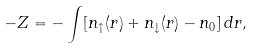Convert formula to latex. <formula><loc_0><loc_0><loc_500><loc_500>- Z = - \int [ n _ { \uparrow } ( r ) + n _ { \downarrow } ( r ) - n _ { 0 } ] \, d { r } ,</formula> 